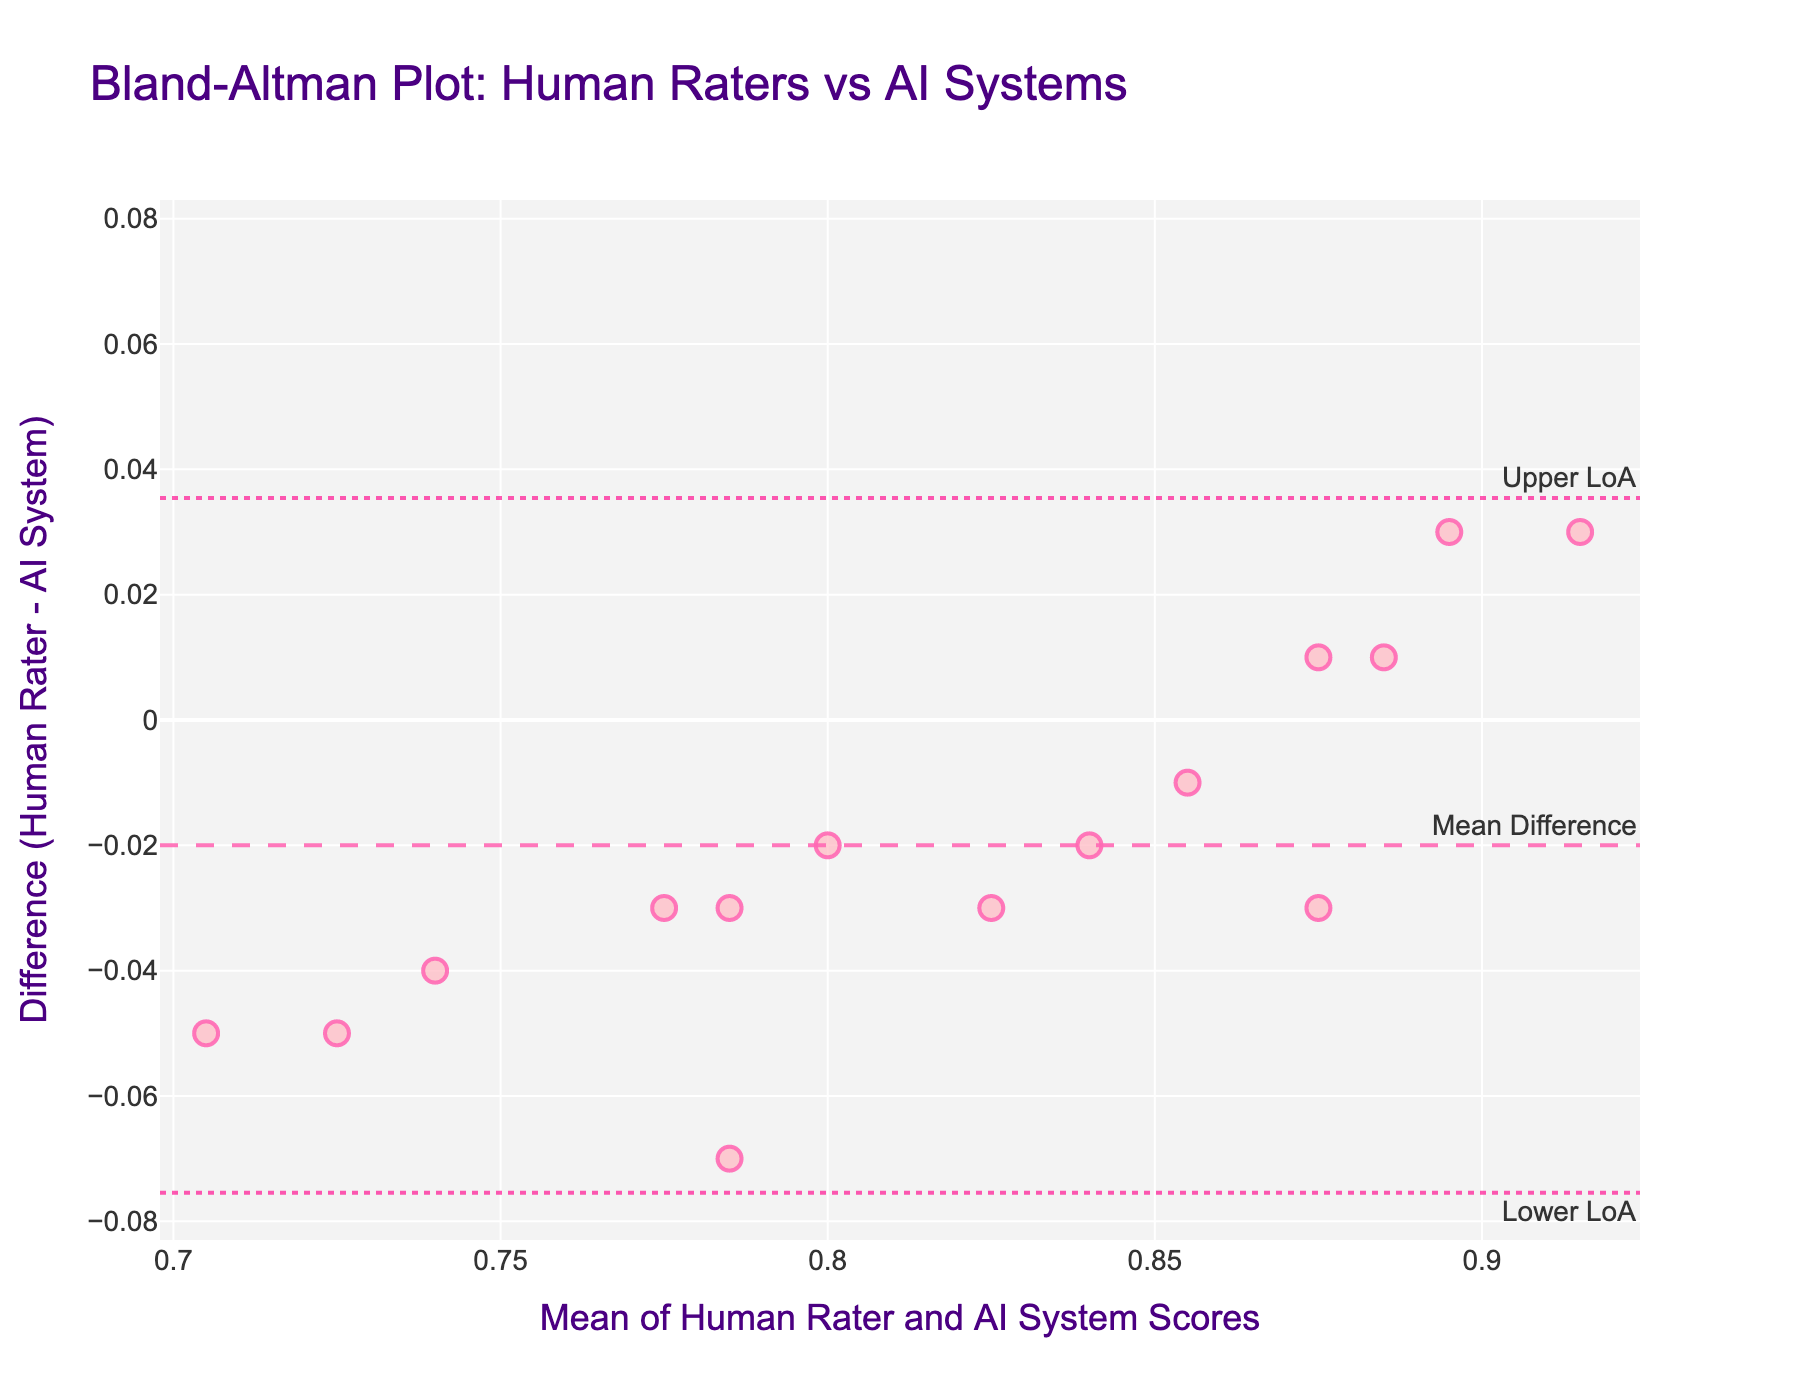What's the title of the plot? Read the title text at the top of the figure, which is clearly visible and often larger in font size than other text elements.
Answer: Bland-Altman Plot: Human Raters vs AI Systems What's the range of the y-axis in the plot? The y-axis range is determined by the plotted data and the set limits in the figure. In this case, look at the y-axis ticks to see the minimum and maximum values it covers.
Answer: -0.06 to 0.06 What is the mean difference between the human raters and AI systems for assessing virtual character expressions? The mean difference is indicated by the dashed line on the plot that is annotated as "Mean Difference."
Answer: -0.006 Are there more data points above or below the mean difference line? Count the number of points above and below the dashed mean difference line.
Answer: Above What are the upper and lower limits of agreement (LoA) in the plot? The upper and lower limits of agreement are indicated by dotted lines, annotated as "Upper LoA" and "Lower LoA." Check the y-values of these lines.
Answer: Upper: 0.0204, Lower: -0.0324 What's the highest mean score of human raters and AI systems combined? Examine the x-axis to find the highest mean score value, which is near the right-most data point on the x-axis.
Answer: 0.915 How many data points are there in the plot? Count the number of markers (data points) visible in the plot.
Answer: 15 Is there any data point where the human rater’s score is higher than the AI system score for assessing virtual character expressions? Look at the differences (Human Rater - AI System) on the y-axis. A positive value indicates human rater's score is higher.
Answer: Yes What can you conclude about the inter-rater reliability between human raters and AI systems based on the plot? The Bland-Altman plot shows the distribution and spread of differences against the mean scores. If the data points are close to the mean difference line with narrow limits of agreement, it indicates good inter-rater reliability. Check how tightly points are clustered around the mean difference line and the range of limits of agreement.
Answer: Good reliability Which type of questions are suitable for this plot, and why? Bland-Altman plots are suitable for questions about agreement between two measurement methods, such as comparing differences, outliers, and consistency of measurement pairs.
Answer: Comparison and agreement questions 